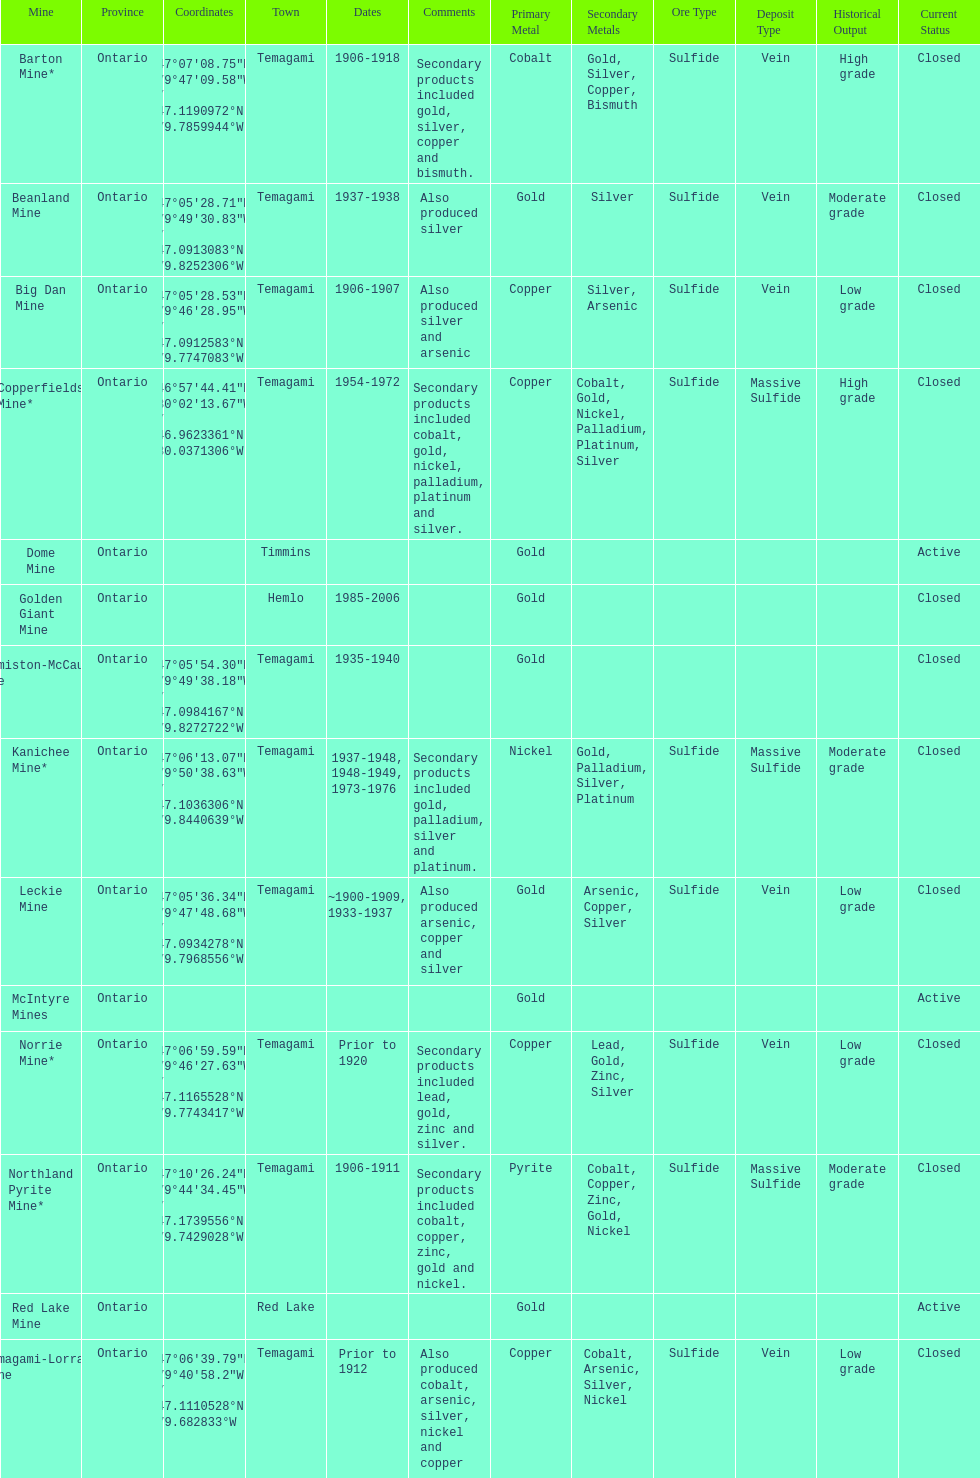Tell me the number of mines that also produced arsenic. 3. 